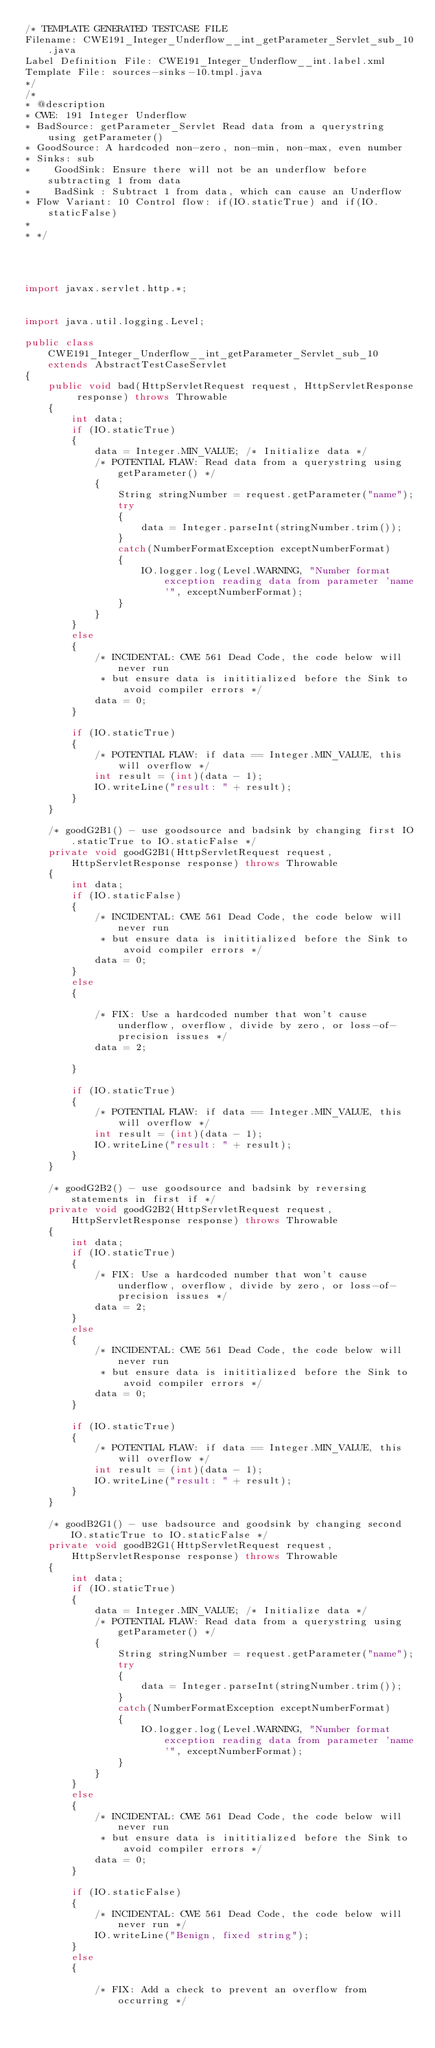<code> <loc_0><loc_0><loc_500><loc_500><_Java_>/* TEMPLATE GENERATED TESTCASE FILE
Filename: CWE191_Integer_Underflow__int_getParameter_Servlet_sub_10.java
Label Definition File: CWE191_Integer_Underflow__int.label.xml
Template File: sources-sinks-10.tmpl.java
*/
/*
* @description
* CWE: 191 Integer Underflow
* BadSource: getParameter_Servlet Read data from a querystring using getParameter()
* GoodSource: A hardcoded non-zero, non-min, non-max, even number
* Sinks: sub
*    GoodSink: Ensure there will not be an underflow before subtracting 1 from data
*    BadSink : Subtract 1 from data, which can cause an Underflow
* Flow Variant: 10 Control flow: if(IO.staticTrue) and if(IO.staticFalse)
*
* */




import javax.servlet.http.*;


import java.util.logging.Level;

public class CWE191_Integer_Underflow__int_getParameter_Servlet_sub_10 extends AbstractTestCaseServlet
{
    public void bad(HttpServletRequest request, HttpServletResponse response) throws Throwable
    {
        int data;
        if (IO.staticTrue)
        {
            data = Integer.MIN_VALUE; /* Initialize data */
            /* POTENTIAL FLAW: Read data from a querystring using getParameter() */
            {
                String stringNumber = request.getParameter("name");
                try
                {
                    data = Integer.parseInt(stringNumber.trim());
                }
                catch(NumberFormatException exceptNumberFormat)
                {
                    IO.logger.log(Level.WARNING, "Number format exception reading data from parameter 'name'", exceptNumberFormat);
                }
            }
        }
        else
        {
            /* INCIDENTAL: CWE 561 Dead Code, the code below will never run
             * but ensure data is inititialized before the Sink to avoid compiler errors */
            data = 0;
        }

        if (IO.staticTrue)
        {
            /* POTENTIAL FLAW: if data == Integer.MIN_VALUE, this will overflow */
            int result = (int)(data - 1);
            IO.writeLine("result: " + result);
        }
    }

    /* goodG2B1() - use goodsource and badsink by changing first IO.staticTrue to IO.staticFalse */
    private void goodG2B1(HttpServletRequest request, HttpServletResponse response) throws Throwable
    {
        int data;
        if (IO.staticFalse)
        {
            /* INCIDENTAL: CWE 561 Dead Code, the code below will never run
             * but ensure data is inititialized before the Sink to avoid compiler errors */
            data = 0;
        }
        else
        {

            /* FIX: Use a hardcoded number that won't cause underflow, overflow, divide by zero, or loss-of-precision issues */
            data = 2;

        }

        if (IO.staticTrue)
        {
            /* POTENTIAL FLAW: if data == Integer.MIN_VALUE, this will overflow */
            int result = (int)(data - 1);
            IO.writeLine("result: " + result);
        }
    }

    /* goodG2B2() - use goodsource and badsink by reversing statements in first if */
    private void goodG2B2(HttpServletRequest request, HttpServletResponse response) throws Throwable
    {
        int data;
        if (IO.staticTrue)
        {
            /* FIX: Use a hardcoded number that won't cause underflow, overflow, divide by zero, or loss-of-precision issues */
            data = 2;
        }
        else
        {
            /* INCIDENTAL: CWE 561 Dead Code, the code below will never run
             * but ensure data is inititialized before the Sink to avoid compiler errors */
            data = 0;
        }

        if (IO.staticTrue)
        {
            /* POTENTIAL FLAW: if data == Integer.MIN_VALUE, this will overflow */
            int result = (int)(data - 1);
            IO.writeLine("result: " + result);
        }
    }

    /* goodB2G1() - use badsource and goodsink by changing second IO.staticTrue to IO.staticFalse */
    private void goodB2G1(HttpServletRequest request, HttpServletResponse response) throws Throwable
    {
        int data;
        if (IO.staticTrue)
        {
            data = Integer.MIN_VALUE; /* Initialize data */
            /* POTENTIAL FLAW: Read data from a querystring using getParameter() */
            {
                String stringNumber = request.getParameter("name");
                try
                {
                    data = Integer.parseInt(stringNumber.trim());
                }
                catch(NumberFormatException exceptNumberFormat)
                {
                    IO.logger.log(Level.WARNING, "Number format exception reading data from parameter 'name'", exceptNumberFormat);
                }
            }
        }
        else
        {
            /* INCIDENTAL: CWE 561 Dead Code, the code below will never run
             * but ensure data is inititialized before the Sink to avoid compiler errors */
            data = 0;
        }

        if (IO.staticFalse)
        {
            /* INCIDENTAL: CWE 561 Dead Code, the code below will never run */
            IO.writeLine("Benign, fixed string");
        }
        else
        {

            /* FIX: Add a check to prevent an overflow from occurring */</code> 